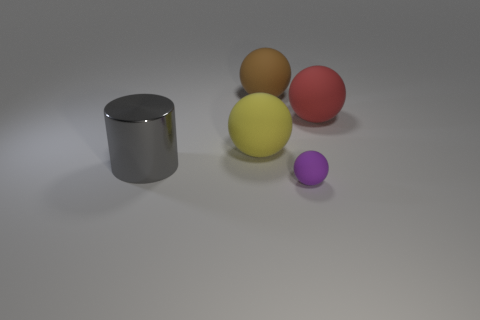There is a purple thing; does it have the same shape as the large thing that is on the right side of the tiny matte object?
Ensure brevity in your answer.  Yes. The brown object that is the same shape as the tiny purple matte thing is what size?
Your response must be concise. Large. Does the metal cylinder have the same color as the matte sphere in front of the gray metallic object?
Your answer should be very brief. No. How many other objects are the same size as the purple matte object?
Provide a succinct answer. 0. The large shiny object that is left of the rubber thing right of the object in front of the metallic cylinder is what shape?
Your answer should be very brief. Cylinder. Do the red matte object and the sphere that is in front of the big yellow sphere have the same size?
Your answer should be compact. No. There is a matte object that is both in front of the large red ball and to the right of the yellow thing; what is its color?
Your answer should be compact. Purple. How many other objects are the same shape as the gray object?
Ensure brevity in your answer.  0. There is a rubber object in front of the big yellow ball; does it have the same color as the matte object that is behind the large red ball?
Give a very brief answer. No. Does the rubber ball to the left of the brown matte thing have the same size as the ball that is right of the purple sphere?
Your answer should be compact. Yes. 